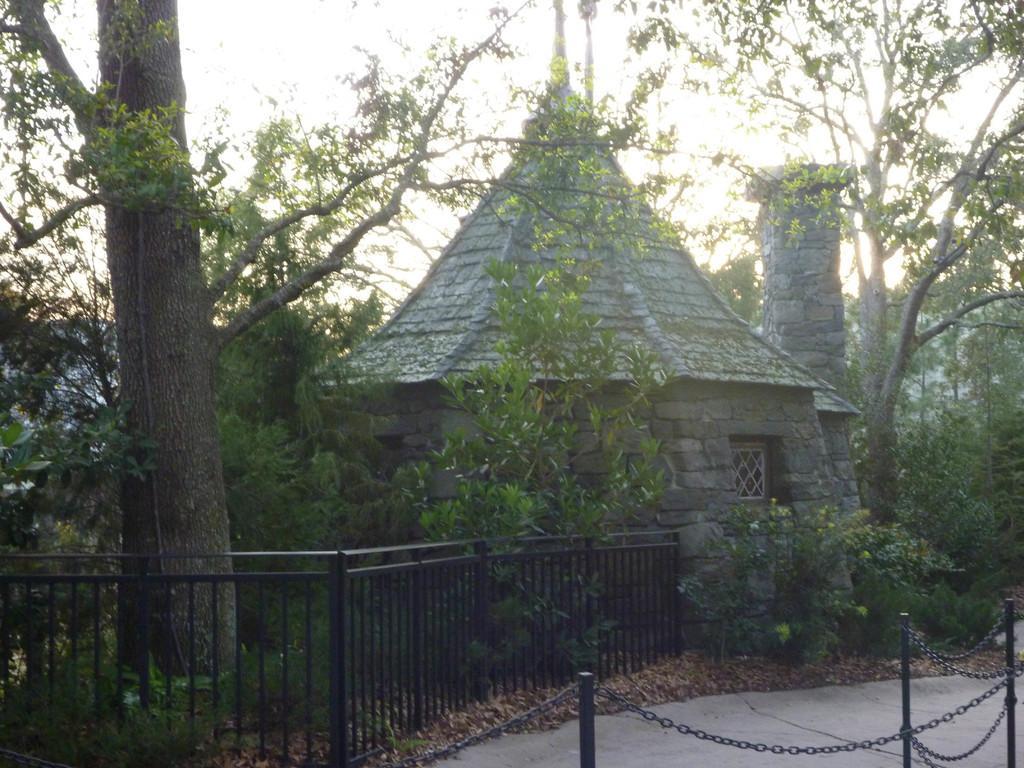Could you give a brief overview of what you see in this image? In this picture we can see poles, chains, trees, plants and house. In the background of the image we can see the sky. 